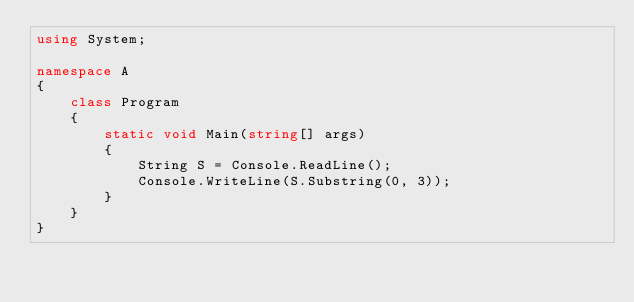<code> <loc_0><loc_0><loc_500><loc_500><_C#_>using System;

namespace A
{
    class Program
    {
        static void Main(string[] args)
        {
            String S = Console.ReadLine();
            Console.WriteLine(S.Substring(0, 3));
        }
    }
}
</code> 